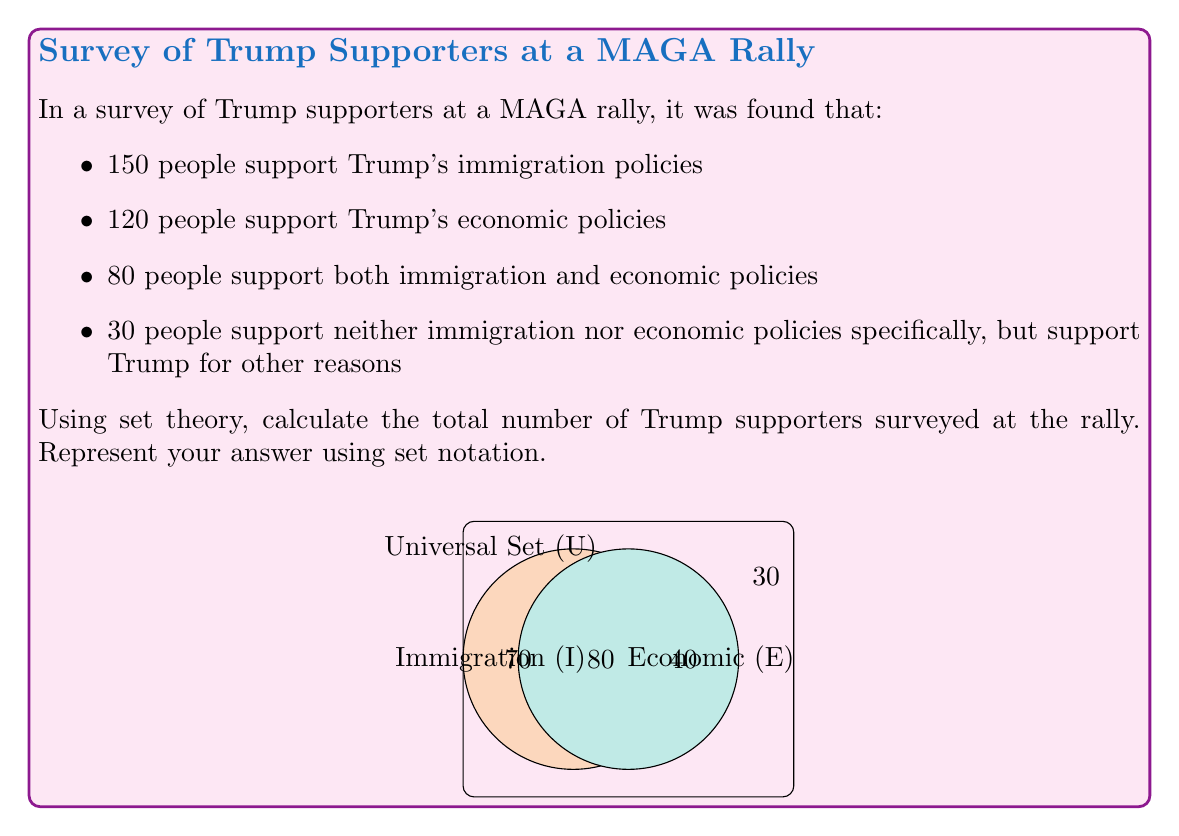Give your solution to this math problem. Let's approach this step-by-step using set theory:

1) Let I be the set of supporters of Trump's immigration policies
   Let E be the set of supporters of Trump's economic policies
   Let U be the universal set of all Trump supporters surveyed

2) Given:
   $|I| = 150$
   $|E| = 120$
   $|I \cap E| = 80$
   Number of supporters in neither set = 30

3) We can use the inclusion-exclusion principle:
   $|I \cup E| = |I| + |E| - |I \cap E|$

4) Substituting the values:
   $|I \cup E| = 150 + 120 - 80 = 190$

5) This gives us the number of supporters who support either immigration or economic policies or both.

6) To get the total number of supporters, we need to add those who support neither:
   $|U| = |I \cup E| + 30 = 190 + 30 = 220$

Therefore, the total number of Trump supporters surveyed is 220.
Answer: $|U| = 220$ 